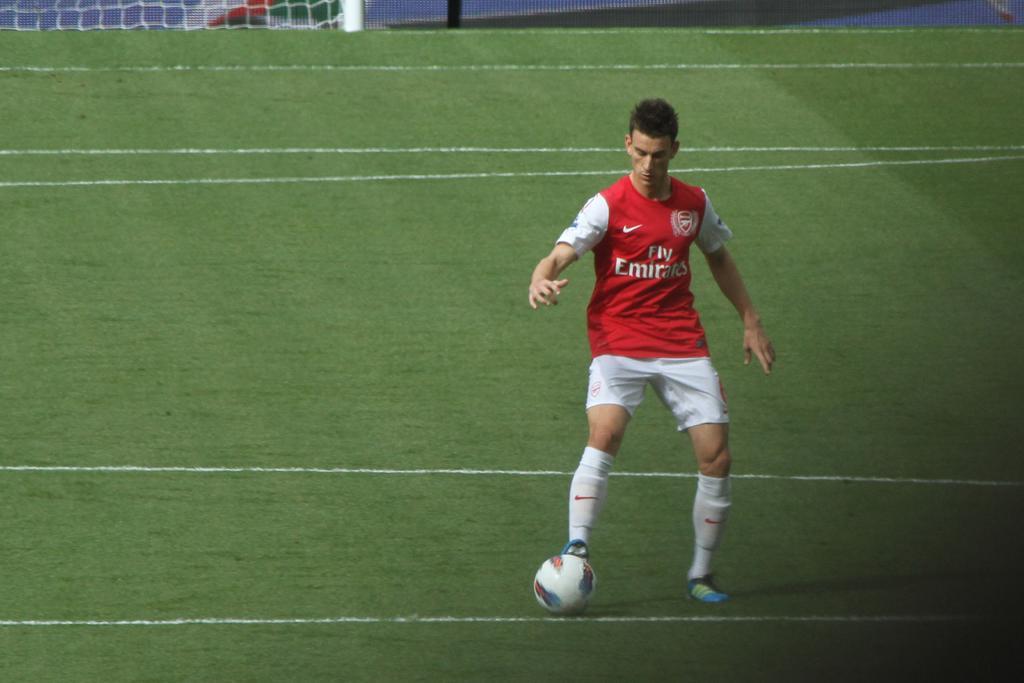Please provide a concise description of this image. In this image, we can see a person wearing T-shirt and shorts is playing a football. We can see the ground covered with grass. We can also see some net and a white colored pole. 